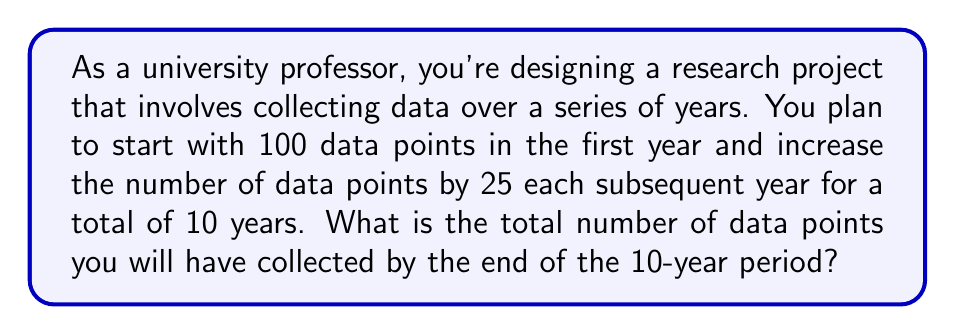Give your solution to this math problem. To solve this problem, we need to recognize that we're dealing with an arithmetic sequence and use the formula for the sum of an arithmetic sequence.

Let's identify the components of our sequence:
1. First term, $a_1 = 100$
2. Common difference, $d = 25$
3. Number of terms, $n = 10$

The formula for the sum of an arithmetic sequence is:

$$S_n = \frac{n}{2}(a_1 + a_n)$$

Where $a_n$ is the last term of the sequence.

To find $a_n$, we can use the arithmetic sequence formula:
$$a_n = a_1 + (n-1)d$$

Substituting our values:
$$a_{10} = 100 + (10-1)25 = 100 + 225 = 325$$

Now we can plug everything into our sum formula:

$$S_{10} = \frac{10}{2}(100 + 325)$$

$$S_{10} = 5(425)$$

$$S_{10} = 2125$$

Therefore, the total number of data points collected over the 10-year period is 2125.
Answer: 2125 data points 